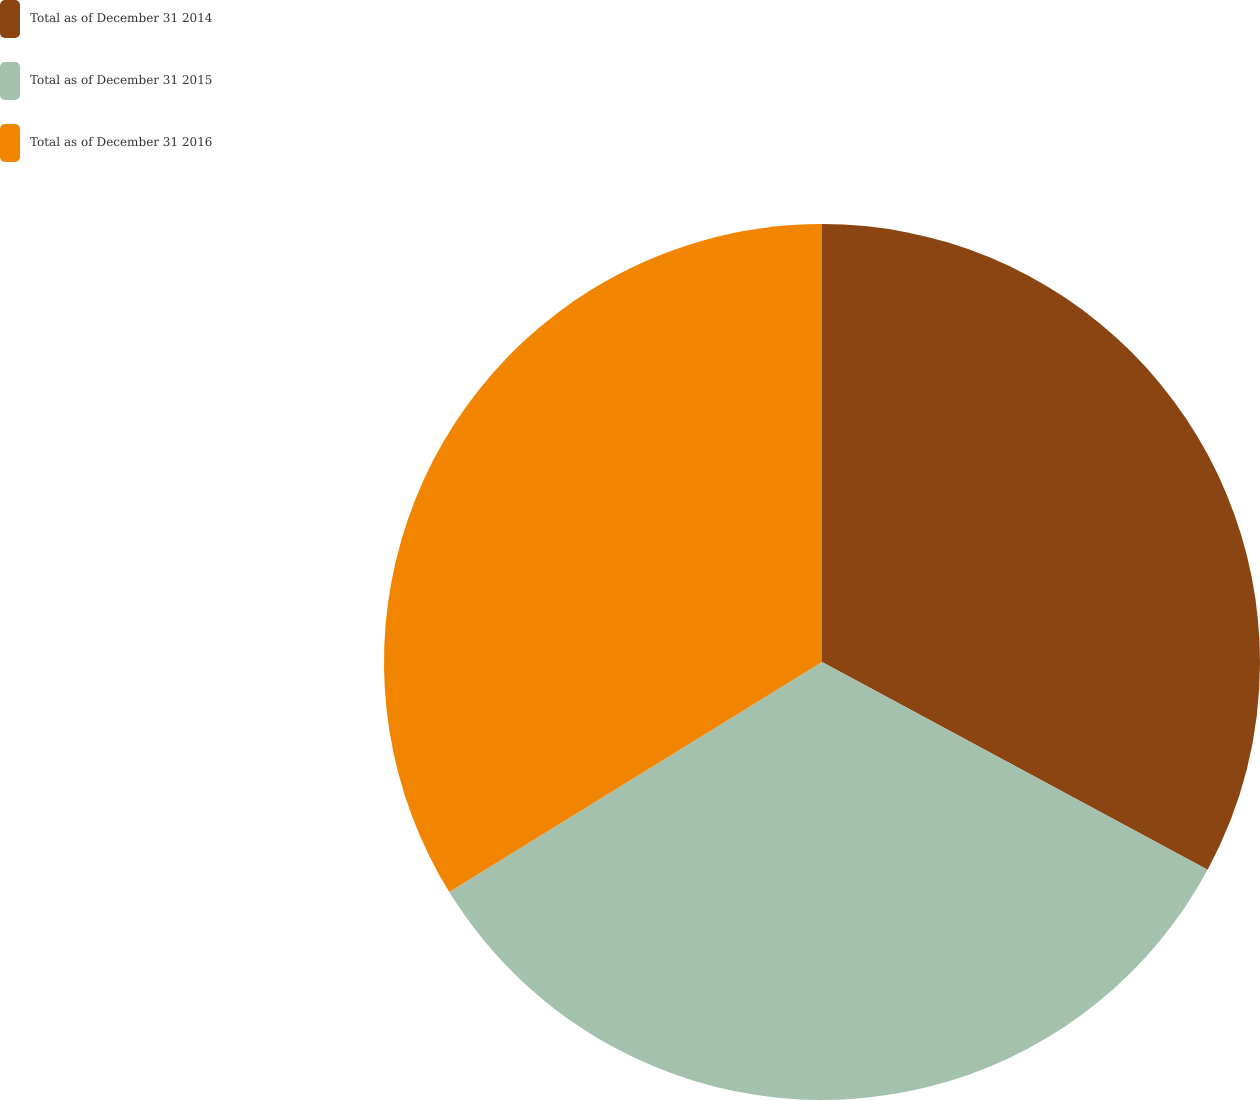<chart> <loc_0><loc_0><loc_500><loc_500><pie_chart><fcel>Total as of December 31 2014<fcel>Total as of December 31 2015<fcel>Total as of December 31 2016<nl><fcel>32.86%<fcel>33.33%<fcel>33.8%<nl></chart> 